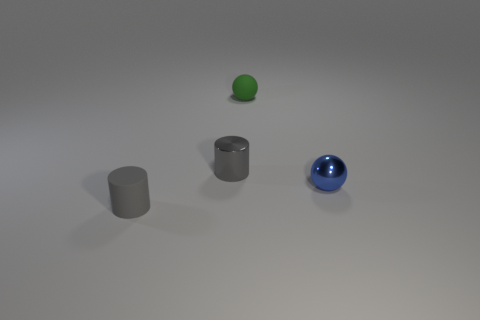How many objects are there in total, and are they all spheres? In total, there are four objects. Two of them, including the green one and the blue one, are spheres. The other two are cylindrical—likely made of metal given their matte finish. 